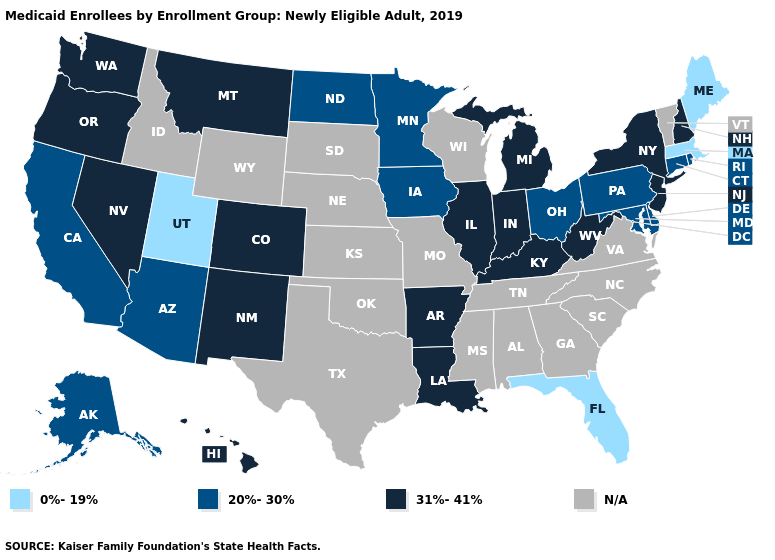Among the states that border Missouri , which have the highest value?
Keep it brief. Arkansas, Illinois, Kentucky. Name the states that have a value in the range N/A?
Write a very short answer. Alabama, Georgia, Idaho, Kansas, Mississippi, Missouri, Nebraska, North Carolina, Oklahoma, South Carolina, South Dakota, Tennessee, Texas, Vermont, Virginia, Wisconsin, Wyoming. Among the states that border Iowa , does Minnesota have the lowest value?
Give a very brief answer. Yes. Does the map have missing data?
Quick response, please. Yes. Name the states that have a value in the range 0%-19%?
Answer briefly. Florida, Maine, Massachusetts, Utah. What is the value of Washington?
Answer briefly. 31%-41%. Among the states that border Delaware , does New Jersey have the highest value?
Write a very short answer. Yes. What is the lowest value in the West?
Be succinct. 0%-19%. Name the states that have a value in the range 20%-30%?
Be succinct. Alaska, Arizona, California, Connecticut, Delaware, Iowa, Maryland, Minnesota, North Dakota, Ohio, Pennsylvania, Rhode Island. Does Alaska have the highest value in the USA?
Quick response, please. No. Name the states that have a value in the range 31%-41%?
Concise answer only. Arkansas, Colorado, Hawaii, Illinois, Indiana, Kentucky, Louisiana, Michigan, Montana, Nevada, New Hampshire, New Jersey, New Mexico, New York, Oregon, Washington, West Virginia. Does the map have missing data?
Answer briefly. Yes. What is the highest value in the USA?
Give a very brief answer. 31%-41%. Name the states that have a value in the range 31%-41%?
Be succinct. Arkansas, Colorado, Hawaii, Illinois, Indiana, Kentucky, Louisiana, Michigan, Montana, Nevada, New Hampshire, New Jersey, New Mexico, New York, Oregon, Washington, West Virginia. Which states have the lowest value in the USA?
Quick response, please. Florida, Maine, Massachusetts, Utah. 